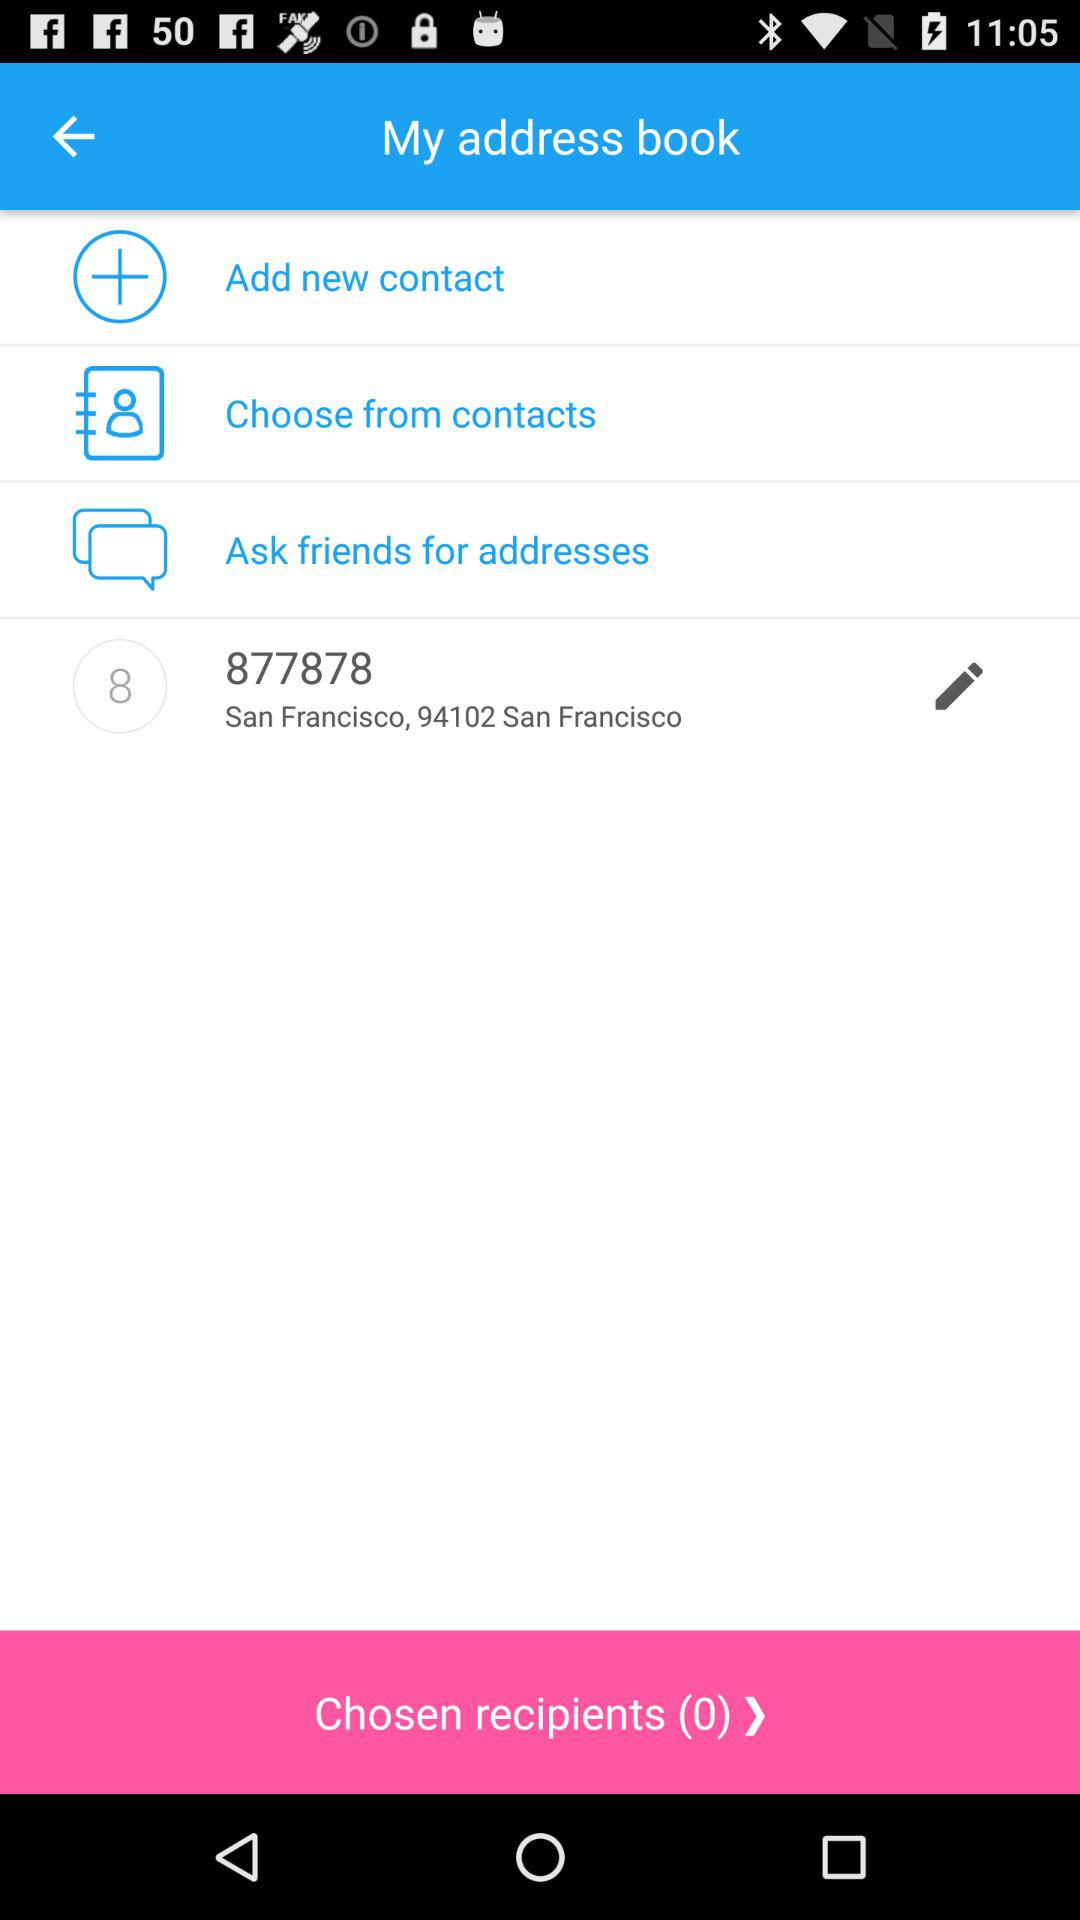How many recipients are chosen? The chosen recipients are 0. 